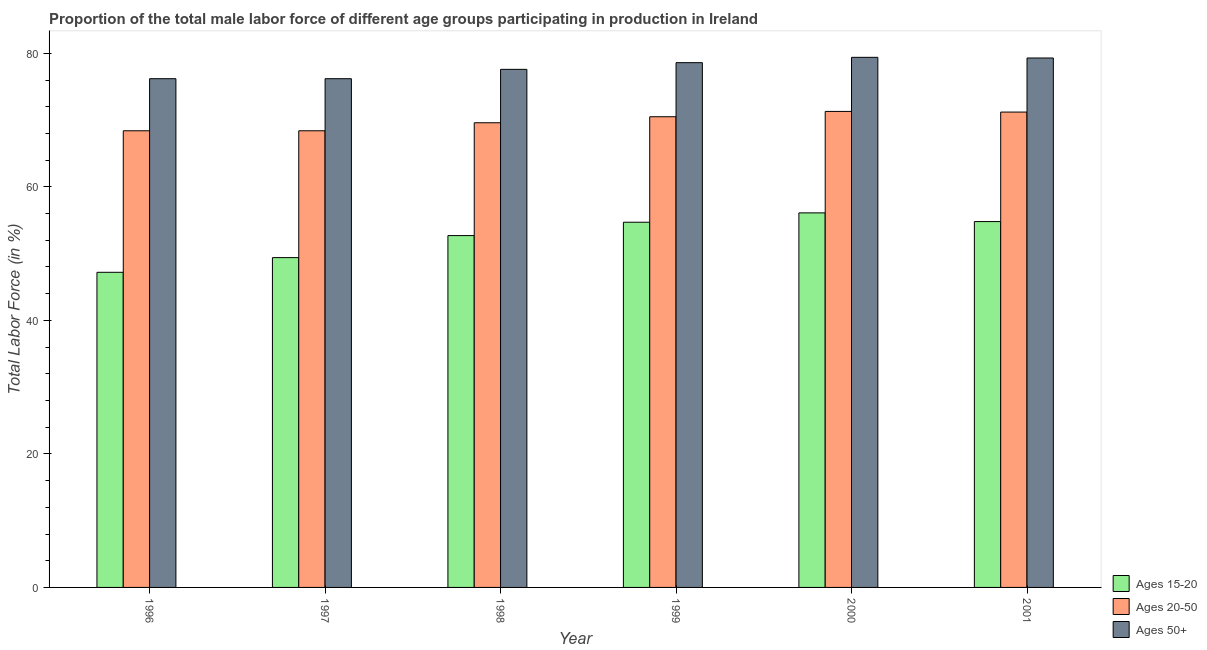How many groups of bars are there?
Offer a terse response. 6. How many bars are there on the 3rd tick from the left?
Ensure brevity in your answer.  3. What is the label of the 2nd group of bars from the left?
Your answer should be very brief. 1997. In how many cases, is the number of bars for a given year not equal to the number of legend labels?
Provide a short and direct response. 0. What is the percentage of male labor force above age 50 in 2000?
Provide a succinct answer. 79.4. Across all years, what is the maximum percentage of male labor force within the age group 20-50?
Give a very brief answer. 71.3. Across all years, what is the minimum percentage of male labor force within the age group 20-50?
Your answer should be compact. 68.4. In which year was the percentage of male labor force within the age group 20-50 maximum?
Provide a succinct answer. 2000. In which year was the percentage of male labor force within the age group 20-50 minimum?
Offer a terse response. 1996. What is the total percentage of male labor force within the age group 20-50 in the graph?
Provide a succinct answer. 419.4. What is the difference between the percentage of male labor force within the age group 20-50 in 1996 and that in 1999?
Your answer should be very brief. -2.1. What is the difference between the percentage of male labor force within the age group 15-20 in 1996 and the percentage of male labor force within the age group 20-50 in 1997?
Ensure brevity in your answer.  -2.2. What is the average percentage of male labor force within the age group 20-50 per year?
Ensure brevity in your answer.  69.9. In how many years, is the percentage of male labor force within the age group 20-50 greater than 64 %?
Your answer should be very brief. 6. What is the ratio of the percentage of male labor force within the age group 15-20 in 1996 to that in 2000?
Your response must be concise. 0.84. What is the difference between the highest and the second highest percentage of male labor force within the age group 15-20?
Give a very brief answer. 1.3. What is the difference between the highest and the lowest percentage of male labor force within the age group 15-20?
Give a very brief answer. 8.9. What does the 1st bar from the left in 2001 represents?
Your response must be concise. Ages 15-20. What does the 3rd bar from the right in 2001 represents?
Provide a short and direct response. Ages 15-20. How many bars are there?
Provide a succinct answer. 18. Are all the bars in the graph horizontal?
Keep it short and to the point. No. How many years are there in the graph?
Your response must be concise. 6. What is the difference between two consecutive major ticks on the Y-axis?
Provide a short and direct response. 20. Does the graph contain any zero values?
Give a very brief answer. No. How are the legend labels stacked?
Make the answer very short. Vertical. What is the title of the graph?
Your answer should be compact. Proportion of the total male labor force of different age groups participating in production in Ireland. Does "Wage workers" appear as one of the legend labels in the graph?
Your response must be concise. No. What is the label or title of the Y-axis?
Ensure brevity in your answer.  Total Labor Force (in %). What is the Total Labor Force (in %) in Ages 15-20 in 1996?
Ensure brevity in your answer.  47.2. What is the Total Labor Force (in %) in Ages 20-50 in 1996?
Your answer should be very brief. 68.4. What is the Total Labor Force (in %) of Ages 50+ in 1996?
Keep it short and to the point. 76.2. What is the Total Labor Force (in %) of Ages 15-20 in 1997?
Provide a succinct answer. 49.4. What is the Total Labor Force (in %) in Ages 20-50 in 1997?
Your answer should be very brief. 68.4. What is the Total Labor Force (in %) in Ages 50+ in 1997?
Provide a short and direct response. 76.2. What is the Total Labor Force (in %) in Ages 15-20 in 1998?
Offer a terse response. 52.7. What is the Total Labor Force (in %) in Ages 20-50 in 1998?
Provide a short and direct response. 69.6. What is the Total Labor Force (in %) in Ages 50+ in 1998?
Give a very brief answer. 77.6. What is the Total Labor Force (in %) of Ages 15-20 in 1999?
Your response must be concise. 54.7. What is the Total Labor Force (in %) of Ages 20-50 in 1999?
Give a very brief answer. 70.5. What is the Total Labor Force (in %) in Ages 50+ in 1999?
Your response must be concise. 78.6. What is the Total Labor Force (in %) in Ages 15-20 in 2000?
Provide a short and direct response. 56.1. What is the Total Labor Force (in %) in Ages 20-50 in 2000?
Your response must be concise. 71.3. What is the Total Labor Force (in %) of Ages 50+ in 2000?
Keep it short and to the point. 79.4. What is the Total Labor Force (in %) of Ages 15-20 in 2001?
Offer a terse response. 54.8. What is the Total Labor Force (in %) of Ages 20-50 in 2001?
Your answer should be compact. 71.2. What is the Total Labor Force (in %) of Ages 50+ in 2001?
Provide a succinct answer. 79.3. Across all years, what is the maximum Total Labor Force (in %) in Ages 15-20?
Provide a succinct answer. 56.1. Across all years, what is the maximum Total Labor Force (in %) in Ages 20-50?
Keep it short and to the point. 71.3. Across all years, what is the maximum Total Labor Force (in %) in Ages 50+?
Your answer should be compact. 79.4. Across all years, what is the minimum Total Labor Force (in %) in Ages 15-20?
Keep it short and to the point. 47.2. Across all years, what is the minimum Total Labor Force (in %) in Ages 20-50?
Your answer should be very brief. 68.4. Across all years, what is the minimum Total Labor Force (in %) in Ages 50+?
Provide a succinct answer. 76.2. What is the total Total Labor Force (in %) of Ages 15-20 in the graph?
Your answer should be very brief. 314.9. What is the total Total Labor Force (in %) in Ages 20-50 in the graph?
Offer a very short reply. 419.4. What is the total Total Labor Force (in %) of Ages 50+ in the graph?
Make the answer very short. 467.3. What is the difference between the Total Labor Force (in %) in Ages 20-50 in 1996 and that in 1998?
Your answer should be compact. -1.2. What is the difference between the Total Labor Force (in %) in Ages 50+ in 1996 and that in 1998?
Make the answer very short. -1.4. What is the difference between the Total Labor Force (in %) of Ages 15-20 in 1996 and that in 1999?
Make the answer very short. -7.5. What is the difference between the Total Labor Force (in %) in Ages 50+ in 1996 and that in 1999?
Provide a short and direct response. -2.4. What is the difference between the Total Labor Force (in %) of Ages 20-50 in 1996 and that in 2000?
Make the answer very short. -2.9. What is the difference between the Total Labor Force (in %) of Ages 20-50 in 1996 and that in 2001?
Give a very brief answer. -2.8. What is the difference between the Total Labor Force (in %) of Ages 15-20 in 1997 and that in 1998?
Your answer should be compact. -3.3. What is the difference between the Total Labor Force (in %) in Ages 50+ in 1997 and that in 1999?
Provide a short and direct response. -2.4. What is the difference between the Total Labor Force (in %) in Ages 50+ in 1997 and that in 2000?
Offer a very short reply. -3.2. What is the difference between the Total Labor Force (in %) in Ages 20-50 in 1997 and that in 2001?
Make the answer very short. -2.8. What is the difference between the Total Labor Force (in %) of Ages 15-20 in 1999 and that in 2001?
Offer a terse response. -0.1. What is the difference between the Total Labor Force (in %) of Ages 20-50 in 1999 and that in 2001?
Ensure brevity in your answer.  -0.7. What is the difference between the Total Labor Force (in %) in Ages 50+ in 1999 and that in 2001?
Your response must be concise. -0.7. What is the difference between the Total Labor Force (in %) of Ages 15-20 in 2000 and that in 2001?
Offer a terse response. 1.3. What is the difference between the Total Labor Force (in %) in Ages 20-50 in 2000 and that in 2001?
Your response must be concise. 0.1. What is the difference between the Total Labor Force (in %) in Ages 15-20 in 1996 and the Total Labor Force (in %) in Ages 20-50 in 1997?
Your response must be concise. -21.2. What is the difference between the Total Labor Force (in %) in Ages 15-20 in 1996 and the Total Labor Force (in %) in Ages 20-50 in 1998?
Offer a very short reply. -22.4. What is the difference between the Total Labor Force (in %) of Ages 15-20 in 1996 and the Total Labor Force (in %) of Ages 50+ in 1998?
Offer a terse response. -30.4. What is the difference between the Total Labor Force (in %) of Ages 20-50 in 1996 and the Total Labor Force (in %) of Ages 50+ in 1998?
Keep it short and to the point. -9.2. What is the difference between the Total Labor Force (in %) in Ages 15-20 in 1996 and the Total Labor Force (in %) in Ages 20-50 in 1999?
Your answer should be compact. -23.3. What is the difference between the Total Labor Force (in %) of Ages 15-20 in 1996 and the Total Labor Force (in %) of Ages 50+ in 1999?
Provide a short and direct response. -31.4. What is the difference between the Total Labor Force (in %) in Ages 20-50 in 1996 and the Total Labor Force (in %) in Ages 50+ in 1999?
Offer a terse response. -10.2. What is the difference between the Total Labor Force (in %) of Ages 15-20 in 1996 and the Total Labor Force (in %) of Ages 20-50 in 2000?
Offer a terse response. -24.1. What is the difference between the Total Labor Force (in %) in Ages 15-20 in 1996 and the Total Labor Force (in %) in Ages 50+ in 2000?
Your answer should be compact. -32.2. What is the difference between the Total Labor Force (in %) of Ages 20-50 in 1996 and the Total Labor Force (in %) of Ages 50+ in 2000?
Offer a very short reply. -11. What is the difference between the Total Labor Force (in %) in Ages 15-20 in 1996 and the Total Labor Force (in %) in Ages 20-50 in 2001?
Give a very brief answer. -24. What is the difference between the Total Labor Force (in %) of Ages 15-20 in 1996 and the Total Labor Force (in %) of Ages 50+ in 2001?
Ensure brevity in your answer.  -32.1. What is the difference between the Total Labor Force (in %) in Ages 20-50 in 1996 and the Total Labor Force (in %) in Ages 50+ in 2001?
Your answer should be compact. -10.9. What is the difference between the Total Labor Force (in %) of Ages 15-20 in 1997 and the Total Labor Force (in %) of Ages 20-50 in 1998?
Provide a short and direct response. -20.2. What is the difference between the Total Labor Force (in %) in Ages 15-20 in 1997 and the Total Labor Force (in %) in Ages 50+ in 1998?
Ensure brevity in your answer.  -28.2. What is the difference between the Total Labor Force (in %) in Ages 20-50 in 1997 and the Total Labor Force (in %) in Ages 50+ in 1998?
Give a very brief answer. -9.2. What is the difference between the Total Labor Force (in %) of Ages 15-20 in 1997 and the Total Labor Force (in %) of Ages 20-50 in 1999?
Offer a terse response. -21.1. What is the difference between the Total Labor Force (in %) of Ages 15-20 in 1997 and the Total Labor Force (in %) of Ages 50+ in 1999?
Offer a very short reply. -29.2. What is the difference between the Total Labor Force (in %) in Ages 20-50 in 1997 and the Total Labor Force (in %) in Ages 50+ in 1999?
Offer a terse response. -10.2. What is the difference between the Total Labor Force (in %) of Ages 15-20 in 1997 and the Total Labor Force (in %) of Ages 20-50 in 2000?
Offer a terse response. -21.9. What is the difference between the Total Labor Force (in %) in Ages 15-20 in 1997 and the Total Labor Force (in %) in Ages 20-50 in 2001?
Keep it short and to the point. -21.8. What is the difference between the Total Labor Force (in %) of Ages 15-20 in 1997 and the Total Labor Force (in %) of Ages 50+ in 2001?
Your answer should be compact. -29.9. What is the difference between the Total Labor Force (in %) in Ages 15-20 in 1998 and the Total Labor Force (in %) in Ages 20-50 in 1999?
Your answer should be compact. -17.8. What is the difference between the Total Labor Force (in %) of Ages 15-20 in 1998 and the Total Labor Force (in %) of Ages 50+ in 1999?
Give a very brief answer. -25.9. What is the difference between the Total Labor Force (in %) of Ages 20-50 in 1998 and the Total Labor Force (in %) of Ages 50+ in 1999?
Your answer should be compact. -9. What is the difference between the Total Labor Force (in %) in Ages 15-20 in 1998 and the Total Labor Force (in %) in Ages 20-50 in 2000?
Your answer should be compact. -18.6. What is the difference between the Total Labor Force (in %) of Ages 15-20 in 1998 and the Total Labor Force (in %) of Ages 50+ in 2000?
Provide a succinct answer. -26.7. What is the difference between the Total Labor Force (in %) in Ages 15-20 in 1998 and the Total Labor Force (in %) in Ages 20-50 in 2001?
Provide a short and direct response. -18.5. What is the difference between the Total Labor Force (in %) of Ages 15-20 in 1998 and the Total Labor Force (in %) of Ages 50+ in 2001?
Your response must be concise. -26.6. What is the difference between the Total Labor Force (in %) of Ages 20-50 in 1998 and the Total Labor Force (in %) of Ages 50+ in 2001?
Keep it short and to the point. -9.7. What is the difference between the Total Labor Force (in %) of Ages 15-20 in 1999 and the Total Labor Force (in %) of Ages 20-50 in 2000?
Make the answer very short. -16.6. What is the difference between the Total Labor Force (in %) of Ages 15-20 in 1999 and the Total Labor Force (in %) of Ages 50+ in 2000?
Ensure brevity in your answer.  -24.7. What is the difference between the Total Labor Force (in %) in Ages 15-20 in 1999 and the Total Labor Force (in %) in Ages 20-50 in 2001?
Ensure brevity in your answer.  -16.5. What is the difference between the Total Labor Force (in %) in Ages 15-20 in 1999 and the Total Labor Force (in %) in Ages 50+ in 2001?
Ensure brevity in your answer.  -24.6. What is the difference between the Total Labor Force (in %) of Ages 20-50 in 1999 and the Total Labor Force (in %) of Ages 50+ in 2001?
Give a very brief answer. -8.8. What is the difference between the Total Labor Force (in %) of Ages 15-20 in 2000 and the Total Labor Force (in %) of Ages 20-50 in 2001?
Offer a terse response. -15.1. What is the difference between the Total Labor Force (in %) in Ages 15-20 in 2000 and the Total Labor Force (in %) in Ages 50+ in 2001?
Provide a short and direct response. -23.2. What is the difference between the Total Labor Force (in %) in Ages 20-50 in 2000 and the Total Labor Force (in %) in Ages 50+ in 2001?
Ensure brevity in your answer.  -8. What is the average Total Labor Force (in %) in Ages 15-20 per year?
Your answer should be very brief. 52.48. What is the average Total Labor Force (in %) in Ages 20-50 per year?
Your answer should be very brief. 69.9. What is the average Total Labor Force (in %) of Ages 50+ per year?
Your answer should be very brief. 77.88. In the year 1996, what is the difference between the Total Labor Force (in %) of Ages 15-20 and Total Labor Force (in %) of Ages 20-50?
Make the answer very short. -21.2. In the year 1996, what is the difference between the Total Labor Force (in %) in Ages 15-20 and Total Labor Force (in %) in Ages 50+?
Your response must be concise. -29. In the year 1996, what is the difference between the Total Labor Force (in %) in Ages 20-50 and Total Labor Force (in %) in Ages 50+?
Your answer should be very brief. -7.8. In the year 1997, what is the difference between the Total Labor Force (in %) of Ages 15-20 and Total Labor Force (in %) of Ages 20-50?
Make the answer very short. -19. In the year 1997, what is the difference between the Total Labor Force (in %) in Ages 15-20 and Total Labor Force (in %) in Ages 50+?
Provide a short and direct response. -26.8. In the year 1998, what is the difference between the Total Labor Force (in %) in Ages 15-20 and Total Labor Force (in %) in Ages 20-50?
Ensure brevity in your answer.  -16.9. In the year 1998, what is the difference between the Total Labor Force (in %) in Ages 15-20 and Total Labor Force (in %) in Ages 50+?
Your answer should be compact. -24.9. In the year 1999, what is the difference between the Total Labor Force (in %) of Ages 15-20 and Total Labor Force (in %) of Ages 20-50?
Offer a terse response. -15.8. In the year 1999, what is the difference between the Total Labor Force (in %) in Ages 15-20 and Total Labor Force (in %) in Ages 50+?
Your response must be concise. -23.9. In the year 2000, what is the difference between the Total Labor Force (in %) in Ages 15-20 and Total Labor Force (in %) in Ages 20-50?
Give a very brief answer. -15.2. In the year 2000, what is the difference between the Total Labor Force (in %) of Ages 15-20 and Total Labor Force (in %) of Ages 50+?
Your response must be concise. -23.3. In the year 2001, what is the difference between the Total Labor Force (in %) in Ages 15-20 and Total Labor Force (in %) in Ages 20-50?
Give a very brief answer. -16.4. In the year 2001, what is the difference between the Total Labor Force (in %) of Ages 15-20 and Total Labor Force (in %) of Ages 50+?
Ensure brevity in your answer.  -24.5. What is the ratio of the Total Labor Force (in %) of Ages 15-20 in 1996 to that in 1997?
Keep it short and to the point. 0.96. What is the ratio of the Total Labor Force (in %) of Ages 15-20 in 1996 to that in 1998?
Keep it short and to the point. 0.9. What is the ratio of the Total Labor Force (in %) of Ages 20-50 in 1996 to that in 1998?
Offer a very short reply. 0.98. What is the ratio of the Total Labor Force (in %) in Ages 15-20 in 1996 to that in 1999?
Keep it short and to the point. 0.86. What is the ratio of the Total Labor Force (in %) of Ages 20-50 in 1996 to that in 1999?
Keep it short and to the point. 0.97. What is the ratio of the Total Labor Force (in %) of Ages 50+ in 1996 to that in 1999?
Provide a short and direct response. 0.97. What is the ratio of the Total Labor Force (in %) in Ages 15-20 in 1996 to that in 2000?
Your answer should be very brief. 0.84. What is the ratio of the Total Labor Force (in %) of Ages 20-50 in 1996 to that in 2000?
Give a very brief answer. 0.96. What is the ratio of the Total Labor Force (in %) in Ages 50+ in 1996 to that in 2000?
Keep it short and to the point. 0.96. What is the ratio of the Total Labor Force (in %) of Ages 15-20 in 1996 to that in 2001?
Make the answer very short. 0.86. What is the ratio of the Total Labor Force (in %) of Ages 20-50 in 1996 to that in 2001?
Give a very brief answer. 0.96. What is the ratio of the Total Labor Force (in %) in Ages 50+ in 1996 to that in 2001?
Provide a succinct answer. 0.96. What is the ratio of the Total Labor Force (in %) in Ages 15-20 in 1997 to that in 1998?
Provide a short and direct response. 0.94. What is the ratio of the Total Labor Force (in %) in Ages 20-50 in 1997 to that in 1998?
Your answer should be very brief. 0.98. What is the ratio of the Total Labor Force (in %) of Ages 15-20 in 1997 to that in 1999?
Your answer should be very brief. 0.9. What is the ratio of the Total Labor Force (in %) in Ages 20-50 in 1997 to that in 1999?
Give a very brief answer. 0.97. What is the ratio of the Total Labor Force (in %) in Ages 50+ in 1997 to that in 1999?
Your answer should be compact. 0.97. What is the ratio of the Total Labor Force (in %) of Ages 15-20 in 1997 to that in 2000?
Your response must be concise. 0.88. What is the ratio of the Total Labor Force (in %) of Ages 20-50 in 1997 to that in 2000?
Provide a succinct answer. 0.96. What is the ratio of the Total Labor Force (in %) in Ages 50+ in 1997 to that in 2000?
Provide a succinct answer. 0.96. What is the ratio of the Total Labor Force (in %) of Ages 15-20 in 1997 to that in 2001?
Provide a succinct answer. 0.9. What is the ratio of the Total Labor Force (in %) of Ages 20-50 in 1997 to that in 2001?
Offer a very short reply. 0.96. What is the ratio of the Total Labor Force (in %) in Ages 50+ in 1997 to that in 2001?
Ensure brevity in your answer.  0.96. What is the ratio of the Total Labor Force (in %) of Ages 15-20 in 1998 to that in 1999?
Provide a succinct answer. 0.96. What is the ratio of the Total Labor Force (in %) in Ages 20-50 in 1998 to that in 1999?
Ensure brevity in your answer.  0.99. What is the ratio of the Total Labor Force (in %) of Ages 50+ in 1998 to that in 1999?
Provide a short and direct response. 0.99. What is the ratio of the Total Labor Force (in %) in Ages 15-20 in 1998 to that in 2000?
Provide a succinct answer. 0.94. What is the ratio of the Total Labor Force (in %) in Ages 20-50 in 1998 to that in 2000?
Make the answer very short. 0.98. What is the ratio of the Total Labor Force (in %) of Ages 50+ in 1998 to that in 2000?
Make the answer very short. 0.98. What is the ratio of the Total Labor Force (in %) in Ages 15-20 in 1998 to that in 2001?
Your answer should be very brief. 0.96. What is the ratio of the Total Labor Force (in %) in Ages 20-50 in 1998 to that in 2001?
Make the answer very short. 0.98. What is the ratio of the Total Labor Force (in %) of Ages 50+ in 1998 to that in 2001?
Your answer should be compact. 0.98. What is the ratio of the Total Labor Force (in %) of Ages 15-20 in 1999 to that in 2000?
Ensure brevity in your answer.  0.97. What is the ratio of the Total Labor Force (in %) in Ages 15-20 in 1999 to that in 2001?
Your answer should be very brief. 1. What is the ratio of the Total Labor Force (in %) in Ages 20-50 in 1999 to that in 2001?
Make the answer very short. 0.99. What is the ratio of the Total Labor Force (in %) of Ages 50+ in 1999 to that in 2001?
Your answer should be compact. 0.99. What is the ratio of the Total Labor Force (in %) of Ages 15-20 in 2000 to that in 2001?
Ensure brevity in your answer.  1.02. What is the ratio of the Total Labor Force (in %) in Ages 50+ in 2000 to that in 2001?
Your answer should be compact. 1. What is the difference between the highest and the second highest Total Labor Force (in %) of Ages 50+?
Offer a terse response. 0.1. What is the difference between the highest and the lowest Total Labor Force (in %) in Ages 20-50?
Make the answer very short. 2.9. 